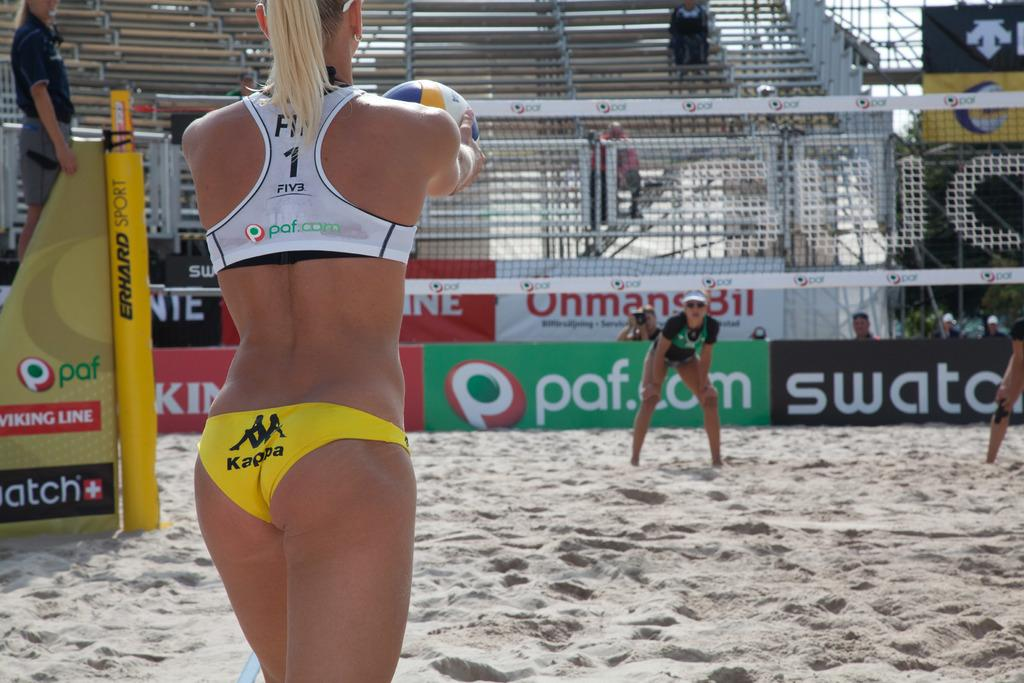<image>
Give a short and clear explanation of the subsequent image. Woman wearing yellow bikini bottoms that say "Kappa" on it. 